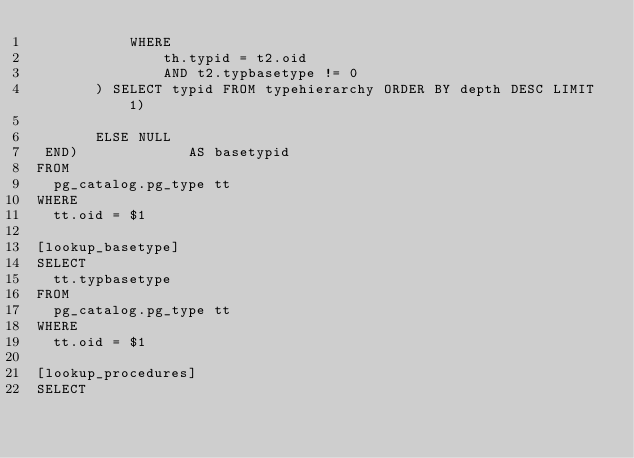Convert code to text. <code><loc_0><loc_0><loc_500><loc_500><_SQL_>           WHERE
               th.typid = t2.oid
               AND t2.typbasetype != 0
       ) SELECT typid FROM typehierarchy ORDER BY depth DESC LIMIT 1)

       ELSE NULL
 END)             AS basetypid
FROM
  pg_catalog.pg_type tt
WHERE
  tt.oid = $1

[lookup_basetype]
SELECT
  tt.typbasetype
FROM
  pg_catalog.pg_type tt
WHERE
  tt.oid = $1

[lookup_procedures]
SELECT</code> 